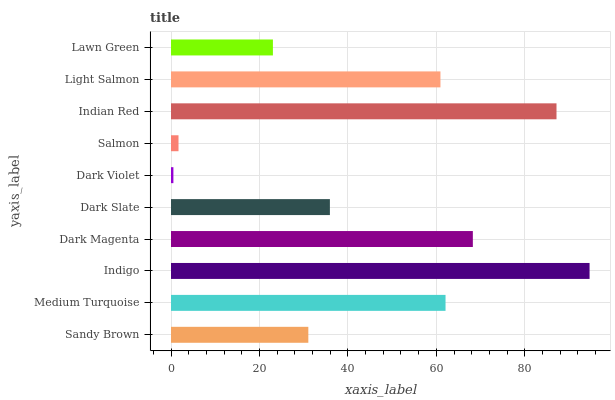Is Dark Violet the minimum?
Answer yes or no. Yes. Is Indigo the maximum?
Answer yes or no. Yes. Is Medium Turquoise the minimum?
Answer yes or no. No. Is Medium Turquoise the maximum?
Answer yes or no. No. Is Medium Turquoise greater than Sandy Brown?
Answer yes or no. Yes. Is Sandy Brown less than Medium Turquoise?
Answer yes or no. Yes. Is Sandy Brown greater than Medium Turquoise?
Answer yes or no. No. Is Medium Turquoise less than Sandy Brown?
Answer yes or no. No. Is Light Salmon the high median?
Answer yes or no. Yes. Is Dark Slate the low median?
Answer yes or no. Yes. Is Sandy Brown the high median?
Answer yes or no. No. Is Dark Magenta the low median?
Answer yes or no. No. 